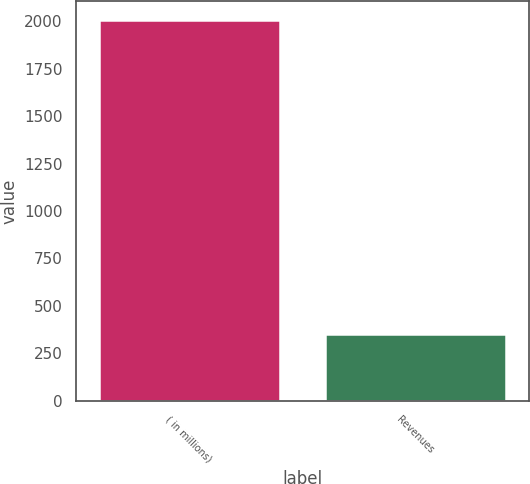Convert chart to OTSL. <chart><loc_0><loc_0><loc_500><loc_500><bar_chart><fcel>( in millions)<fcel>Revenues<nl><fcel>2006<fcel>353<nl></chart> 